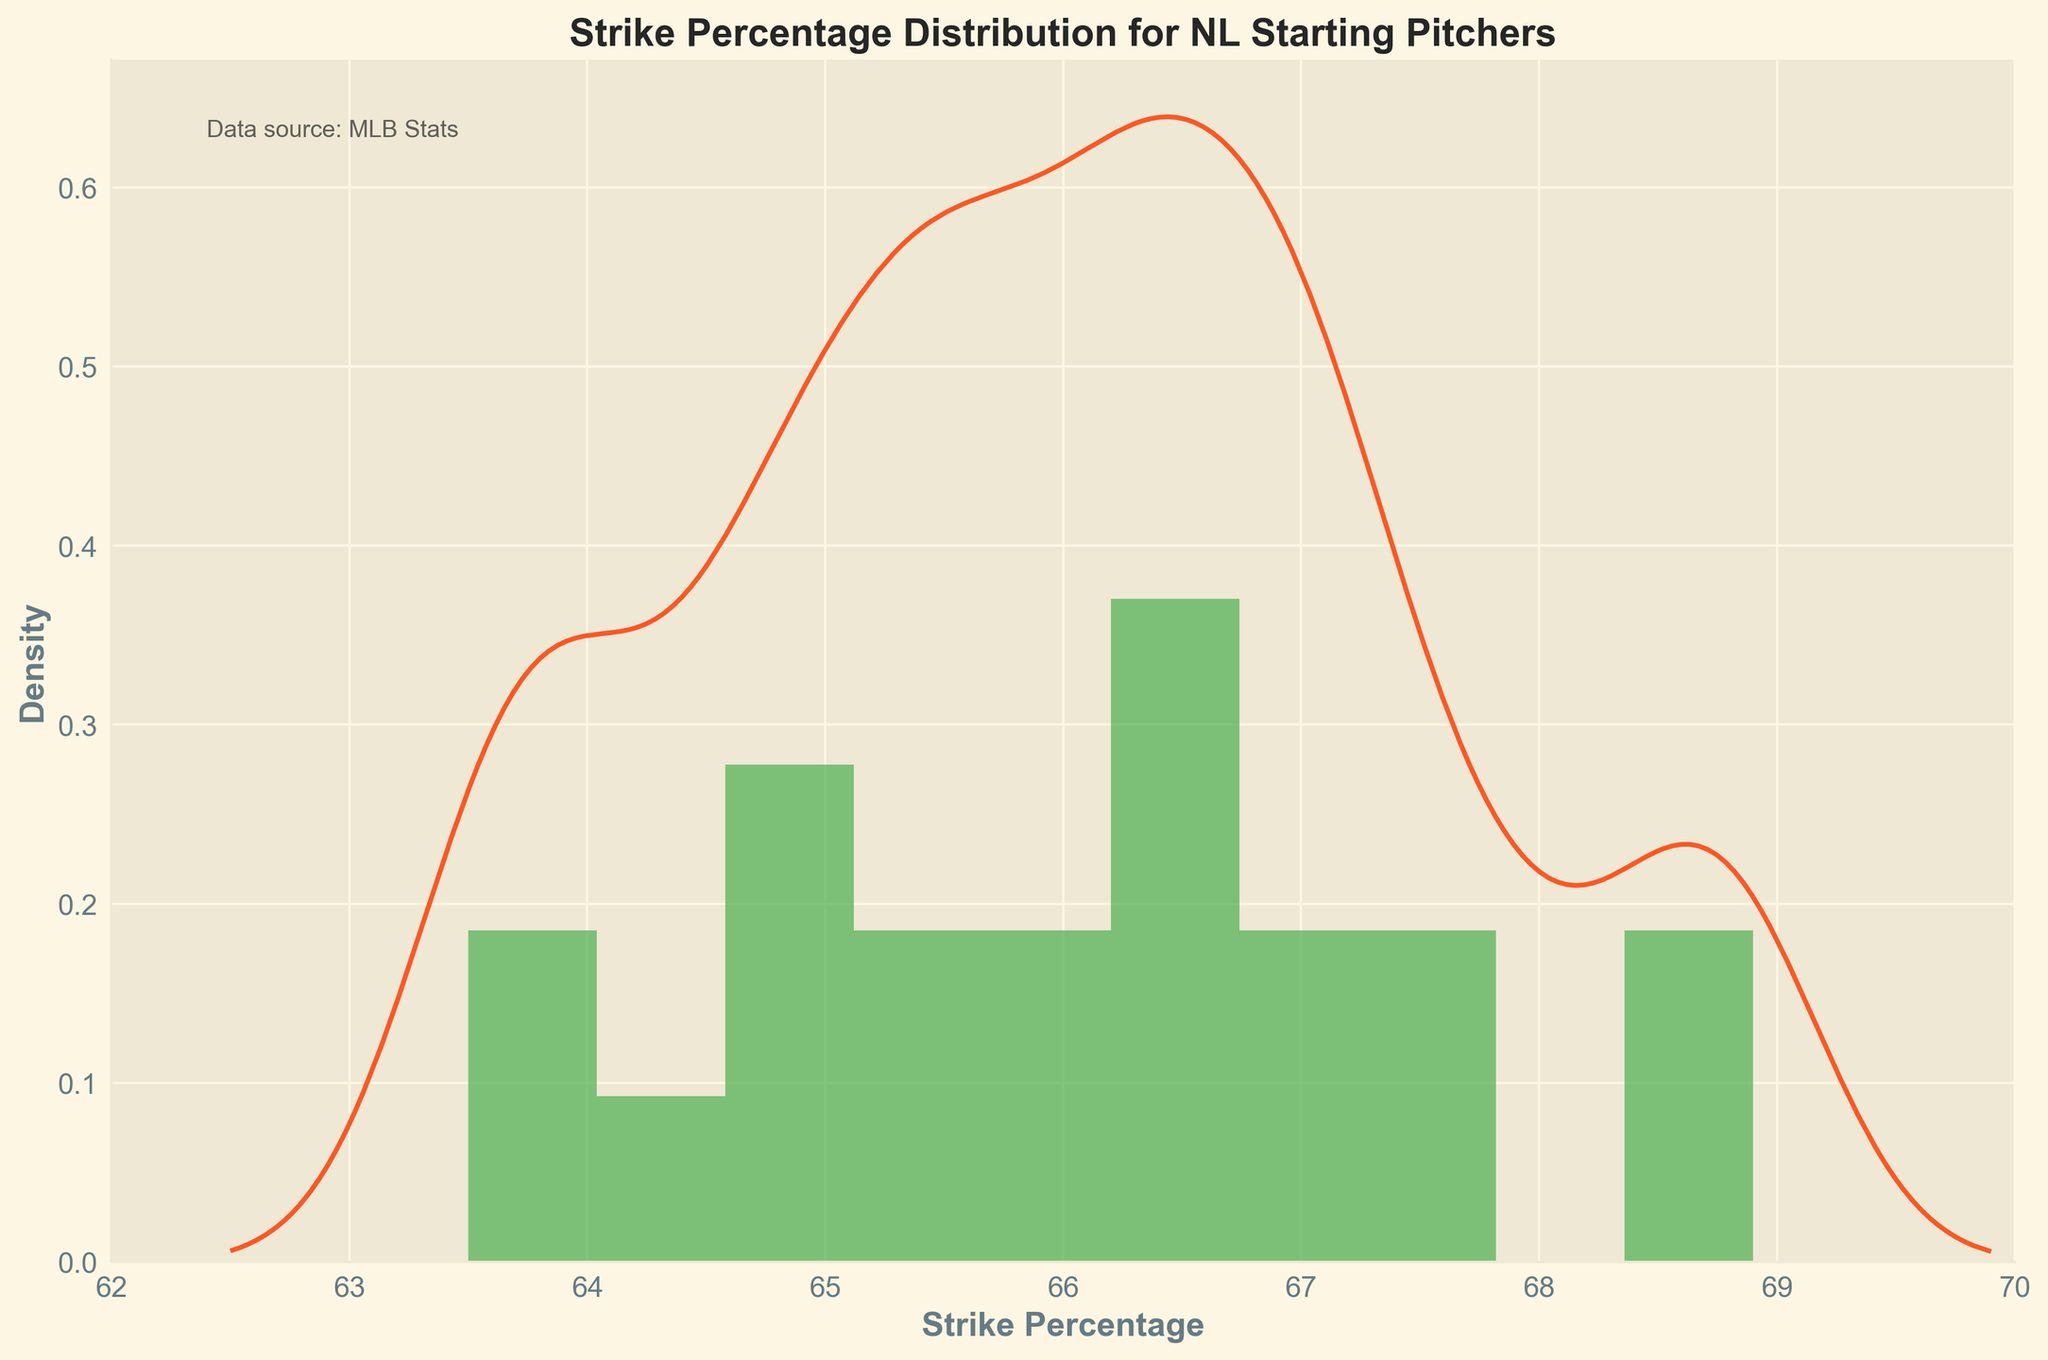What's the title of the figure? The title is prominently displayed at the top of the figure in bold text. Read it directly.
Answer: Strike Percentage Distribution for NL Starting Pitchers What color represents the histogram bars? The histogram bars are colored in a noticeable shade of green. Look for the color used in the bars.
Answer: Green What is the range of the x-axis? Observe the x-axis from the minimum to maximum values indicated.
Answer: 62 to 70 What is the peak density value of the KDE curve? Identify the highest point of the KDE curve along the y-axis.
Answer: Around 0.3 Which pitcher has the highest strike percentage? Locate the highest point in the distribution or the starting pitcher list with the maximum value.
Answer: Clayton Kershaw What's the median strike percentage for the pitchers? Calculate the median by arranging the percentages in order and finding the middle value.
Answer: 66.7 How does the area under the histogram compare to that under the KDE curve? The KDE curve approximates and smoothens the histogram, so both represent probability density functions. The area under both should roughly equal 1.
Answer: Approximately equal What is the strike percentage range with the highest density? Identify the region on the x-axis where the KDE curve and histogram bars reach their peak.
Answer: 66 to 68 Which pitcher is closest to the average strike percentage? First, calculate the average strike percentage then identify the pitcher closest to this value.
Answer: Aaron Nola Is there a clear skew in the distribution? Analyzing the shape of both the histogram and KDE curve shows the direction of skewness, if any.
Answer: Slightly right-skewed What can be inferred from the similarity between the histogram and KDE curve? Both representing the probability density suggests consistency and helps in visualizing the distribution better.
Answer: Distribution consistency 